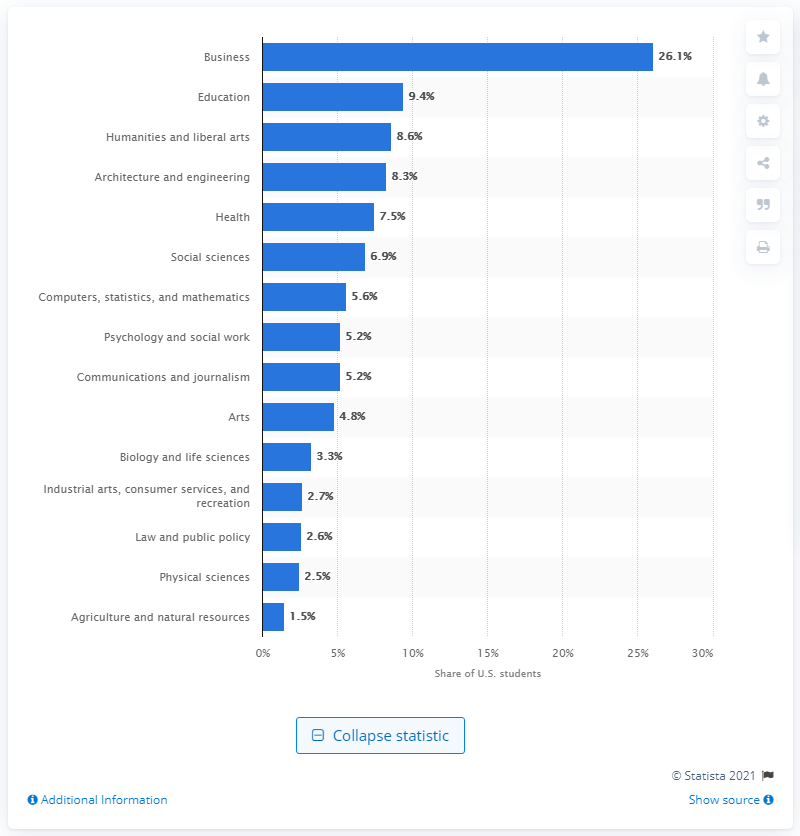Give some essential details in this illustration. In 2013, it was reported that 26.1% of students chose Business Management and Administration as their major. 